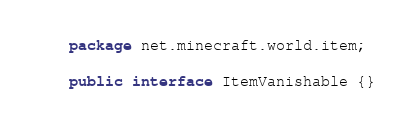<code> <loc_0><loc_0><loc_500><loc_500><_Java_>package net.minecraft.world.item;

public interface ItemVanishable {}
</code> 